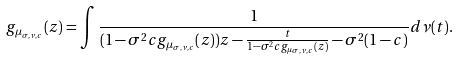Convert formula to latex. <formula><loc_0><loc_0><loc_500><loc_500>g _ { \mu _ { \sigma , \nu , c } } ( z ) = \int \frac { 1 } { ( 1 - \sigma ^ { 2 } c g _ { \mu _ { \sigma , \nu , c } } ( z ) ) z - \frac { t } { 1 - \sigma ^ { 2 } c g _ { \mu _ { \sigma , \nu , c } } ( z ) } - \sigma ^ { 2 } ( 1 - c ) } d \nu ( t ) .</formula> 